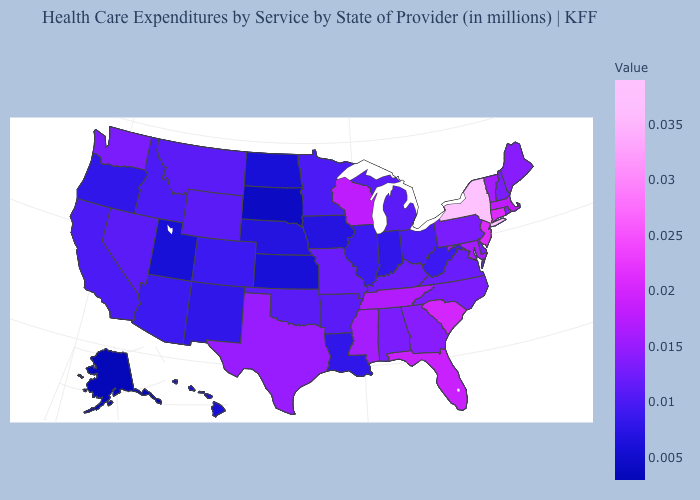Does Maine have a higher value than Louisiana?
Short answer required. Yes. Which states hav the highest value in the Northeast?
Concise answer only. New York. Which states hav the highest value in the MidWest?
Give a very brief answer. Wisconsin. Does Wisconsin have a higher value than Indiana?
Short answer required. Yes. Does Rhode Island have the lowest value in the Northeast?
Short answer required. No. Does Alaska have the lowest value in the USA?
Short answer required. Yes. 